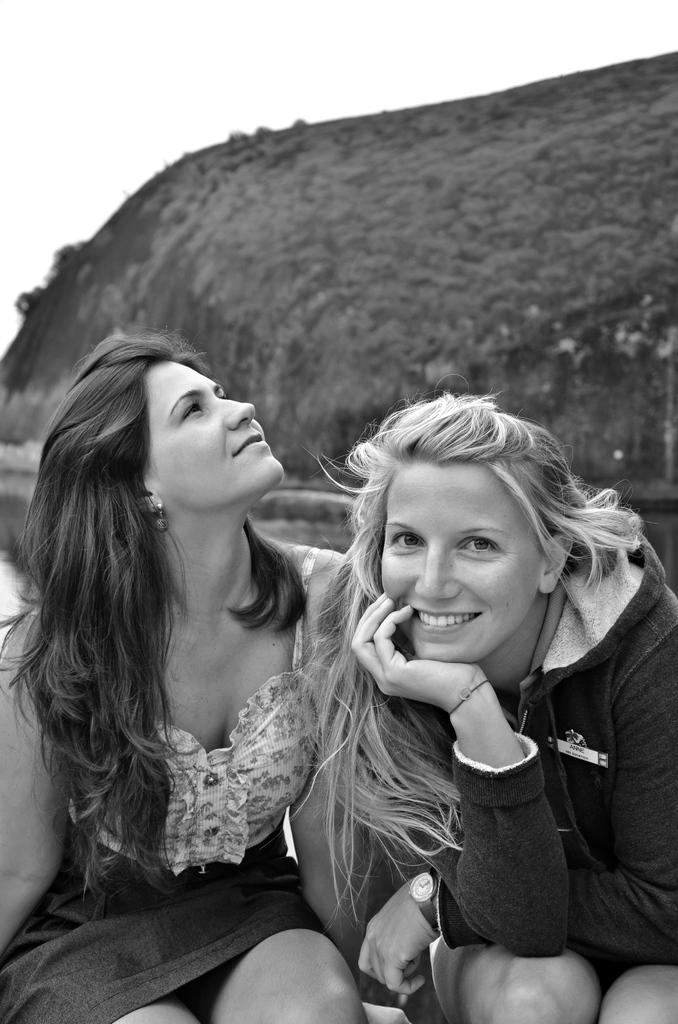How many people are in the image? There are two women in the image. What is the color scheme of the image? The image is black and white. What natural features can be seen in the background of the image? There is a river, a mountain, and the sky visible in the background of the image. What type of spot can be seen on the mountain in the image? There is no spot visible on the mountain in the image. What kind of apparatus is being used by the women in the image? There is no apparatus visible in the image; the women are simply standing in the scene. 